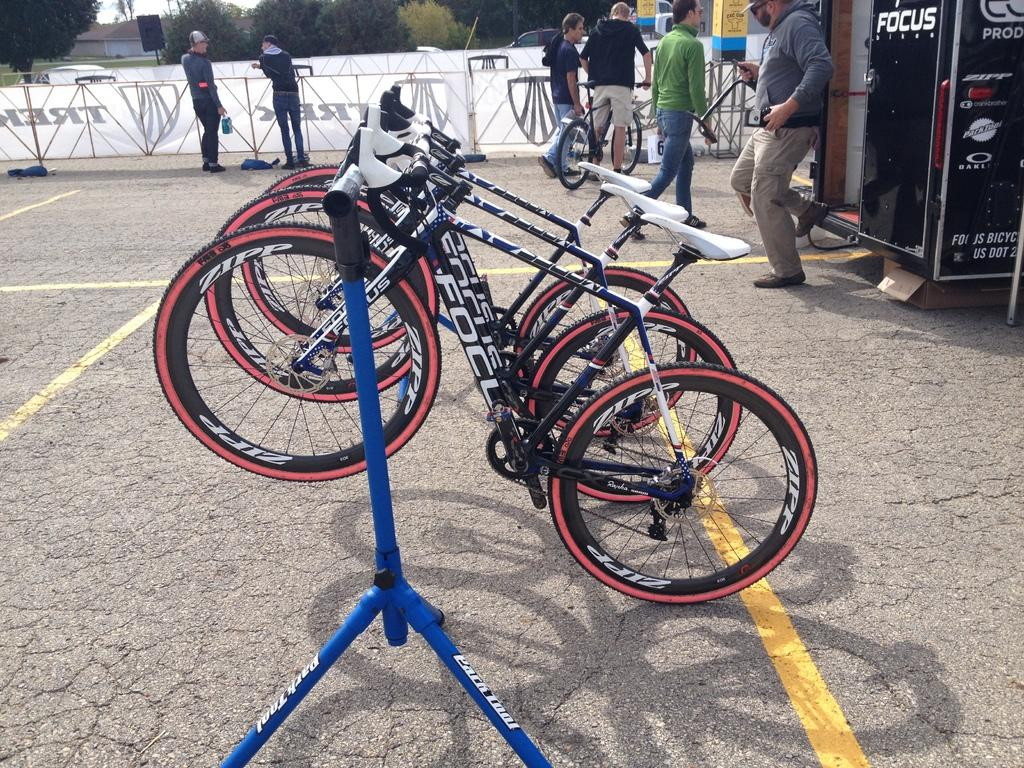What can be seen on the stand in the image? There are bicycles on a stand in the image. What are the people near the bicycles doing? People are standing near the bicycles, and one person is holding a bicycle. What is the purpose of the machine in the image? The purpose of the machine in the image is not specified, but it could be related to bicycle maintenance or repair. What can be seen in the background of the image? There are trees and a building in the background of the image. What type of holiday is being celebrated in the image? There is no indication of a holiday being celebrated in the image. What color is the ink used to write on the bicycles? There is no ink or writing visible on the bicycles in the image. 